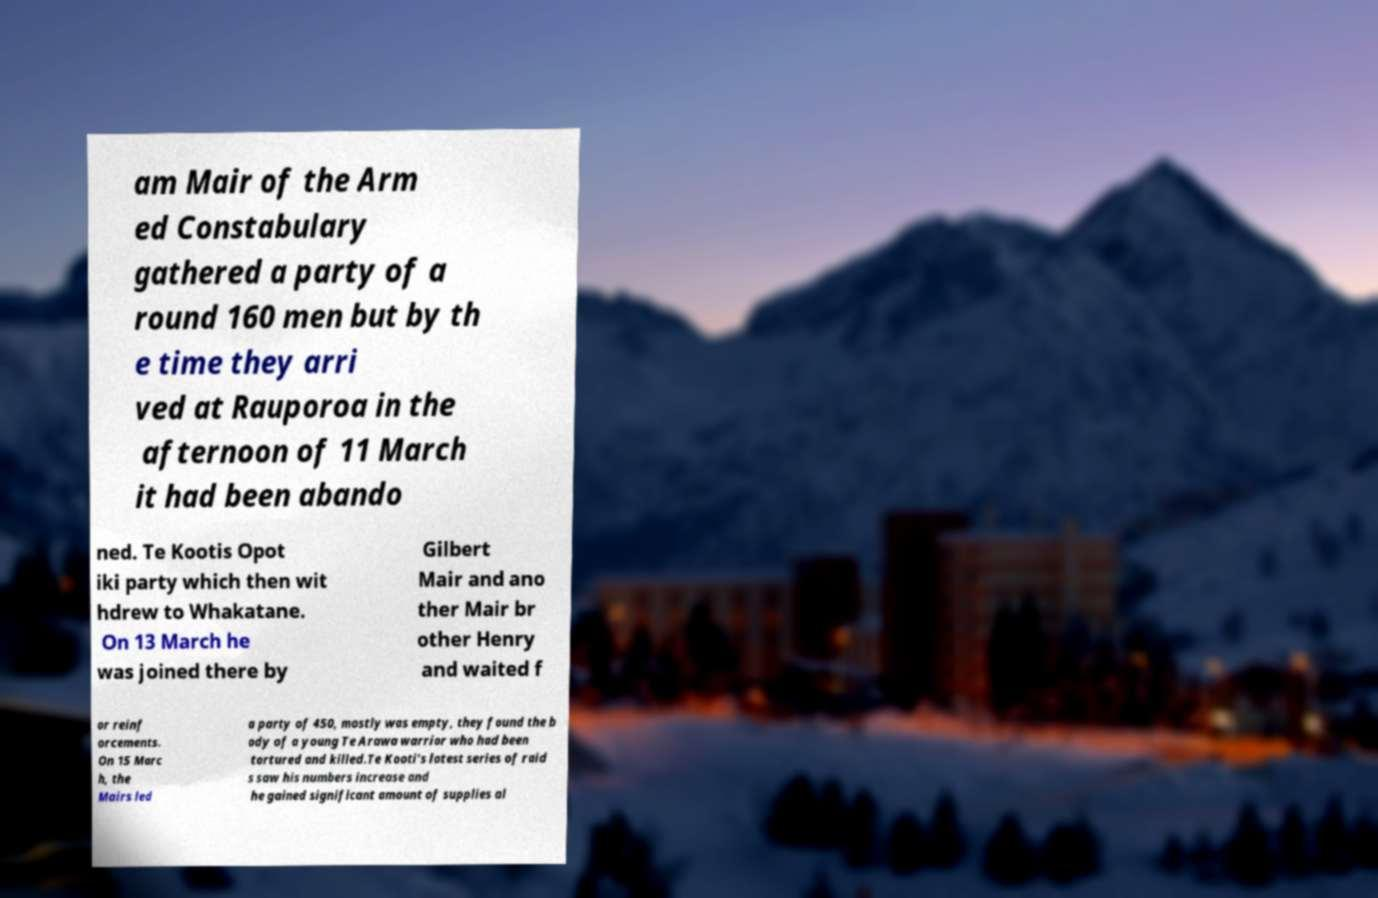For documentation purposes, I need the text within this image transcribed. Could you provide that? am Mair of the Arm ed Constabulary gathered a party of a round 160 men but by th e time they arri ved at Rauporoa in the afternoon of 11 March it had been abando ned. Te Kootis Opot iki party which then wit hdrew to Whakatane. On 13 March he was joined there by Gilbert Mair and ano ther Mair br other Henry and waited f or reinf orcements. On 15 Marc h, the Mairs led a party of 450, mostly was empty, they found the b ody of a young Te Arawa warrior who had been tortured and killed.Te Kooti's latest series of raid s saw his numbers increase and he gained significant amount of supplies al 